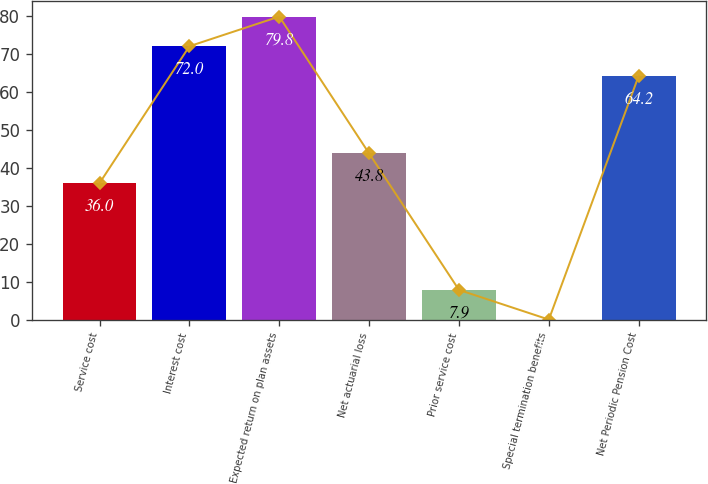Convert chart to OTSL. <chart><loc_0><loc_0><loc_500><loc_500><bar_chart><fcel>Service cost<fcel>Interest cost<fcel>Expected return on plan assets<fcel>Net actuarial loss<fcel>Prior service cost<fcel>Special termination benefits<fcel>Net Periodic Pension Cost<nl><fcel>36<fcel>72<fcel>79.8<fcel>43.8<fcel>7.9<fcel>0.1<fcel>64.2<nl></chart> 